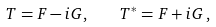<formula> <loc_0><loc_0><loc_500><loc_500>T = F - i G , \quad T ^ { * } = F + i G \, ,</formula> 